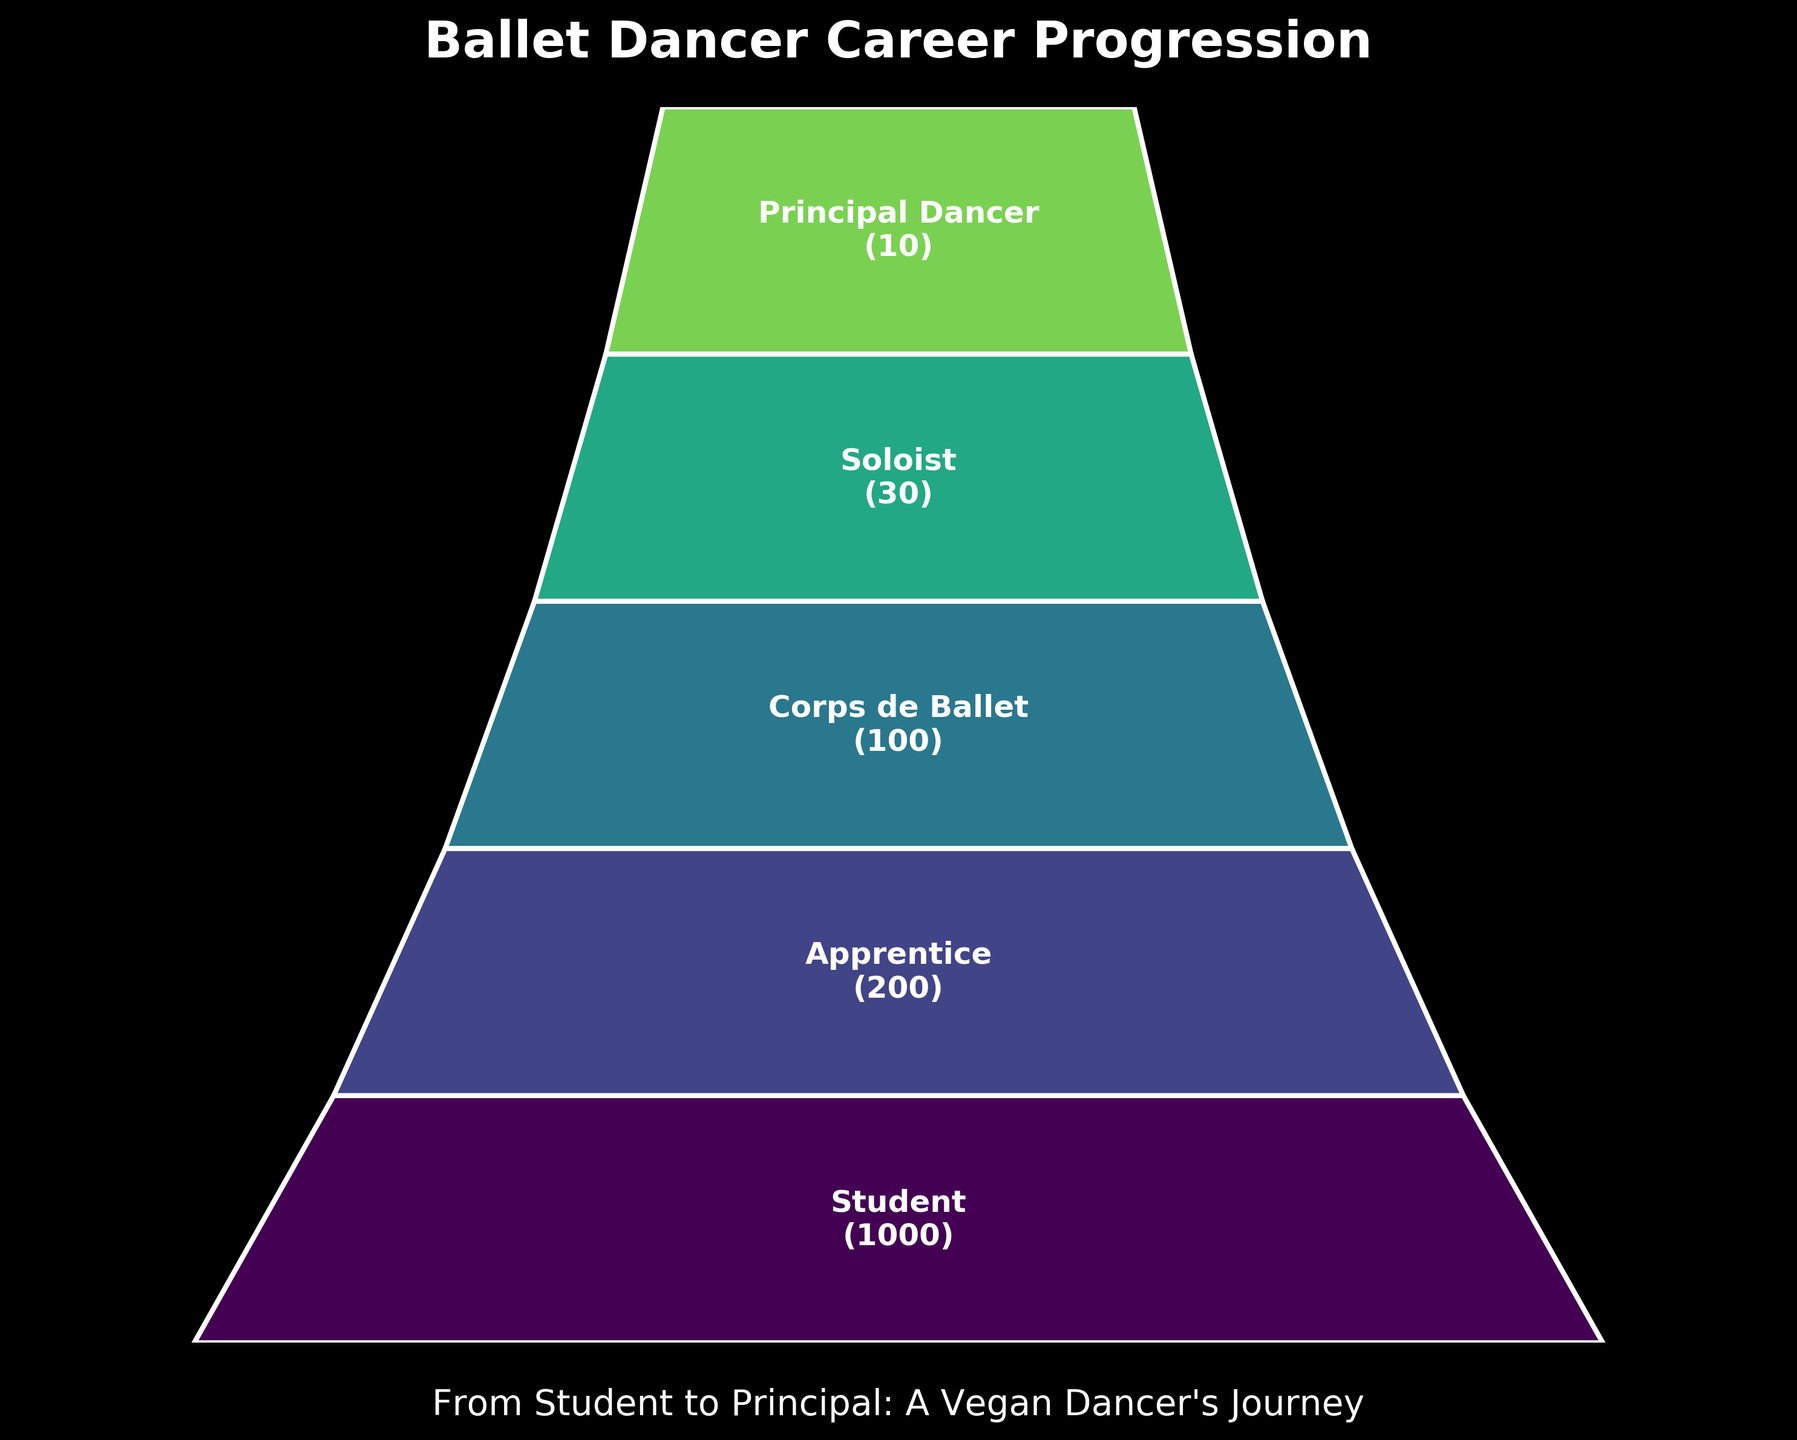what is the title of the chart? The title of the chart is usually the text displayed prominently at the top of the figure. In this case, the title reads "Ballet Dancer Career Progression".
Answer: Ballet Dancer Career Progression How many stages are depicted in the funnel chart? To find the number of stages, count the different labeled sections in the funnel chart. There are five sections labeled "Student," "Apprentice," "Corps de Ballet," "Soloist," and "Principal Dancer."
Answer: 5 Which stage has the largest number of dancers? The stage with the largest number of dancers is typically indicated by the widest section of the funnel at the top. From the labels, the "Student" stage has the largest number, with 1000 dancers.
Answer: Student By how many dancers does the number of "Corps de Ballet" exceed the "Soloist" stage? To find this difference, subtract the number of "Soloist" dancers from the number of "Corps de Ballet" dancers. "Corps de Ballet" has 100 dancers, and "Soloist" has 30, so 100 - 30 = 70.
Answer: 70 How many more stages are there after the "Apprentice" stage? Count the number of stages that come after the "Apprentice" stage. These are "Corps de Ballet," "Soloist," and "Principal Dancer." There are 3 stages following "Apprentice."
Answer: 3 Compare the number of dancers at the "Apprentice" stage to the "Principal Dancer" stage. How many times more dancers are there in the "Apprentice" stage? To compare, divide the number of dancers at the "Apprentice" stage by the number at the "Principal Dancer." There are 200 dancers at "Apprentice" and 10 at "Principal Dancer." 200 / 10 = 20.
Answer: 20 What is the reduction in the number of dancers from the "Student" stage to the "Apprentice" stage? Subtract the number of dancers at the "Apprentice" stage from the "Student" stage. There are 1000 dancers at "Student" and 200 at "Apprentice," so 1000 - 200 = 800.
Answer: 800 What percentage of the total dancers at the "Student" stage advance to the "Principal Dancer" stage? Divide the number of dancers at the "Principal Dancer" stage by the "Student" stage and multiply by 100 to get the percentage. (10 / 1000) * 100 = 1%.
Answer: 1% What two stages have the smallest difference in the number of dancers? Calculate the differences between consecutive stages: "Student"-"Apprentice" (1000-200=800), "Apprentice"-"Corps de Ballet" (200-100=100), "Corps de Ballet"-"Soloist" (100-30=70), "Soloist"-"Principal Dancer" (30-10=20). The smallest difference is 20 between "Soloist" and "Principal Dancer."
Answer: Soloist and Principal Dancer Which stage represents the midpoint in terms of the number of dancers? The midpoint can be inferred by looking at the middle stage in the sorted order by the number of dancers, which is "Corps de Ballet" with 100 dancers.
Answer: Corps de Ballet 